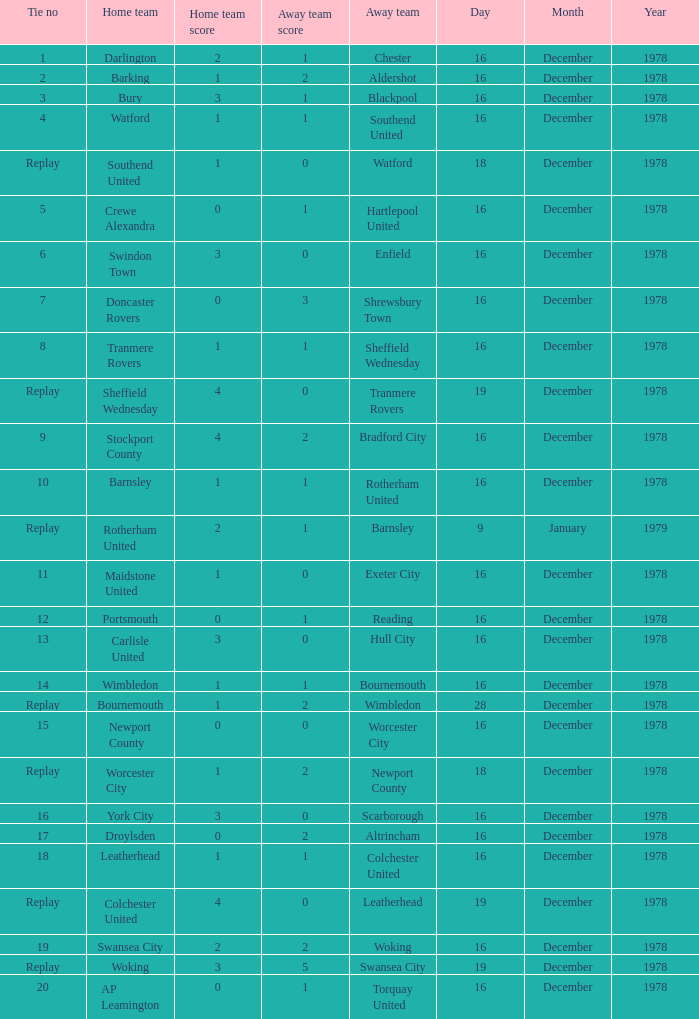Waht was the away team when the home team is colchester united? Leatherhead. 